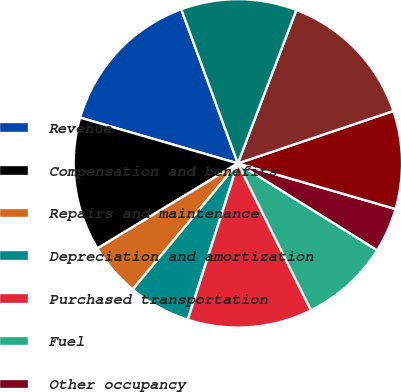Convert chart. <chart><loc_0><loc_0><loc_500><loc_500><pie_chart><fcel>Revenue<fcel>Compensation and benefits<fcel>Repairs and maintenance<fcel>Depreciation and amortization<fcel>Purchased transportation<fcel>Fuel<fcel>Other occupancy<fcel>Other expenses<fcel>Total Operating Expenses<fcel>Operating Profit<nl><fcel>14.91%<fcel>13.16%<fcel>5.26%<fcel>6.14%<fcel>12.28%<fcel>8.77%<fcel>4.39%<fcel>9.65%<fcel>14.03%<fcel>11.4%<nl></chart> 